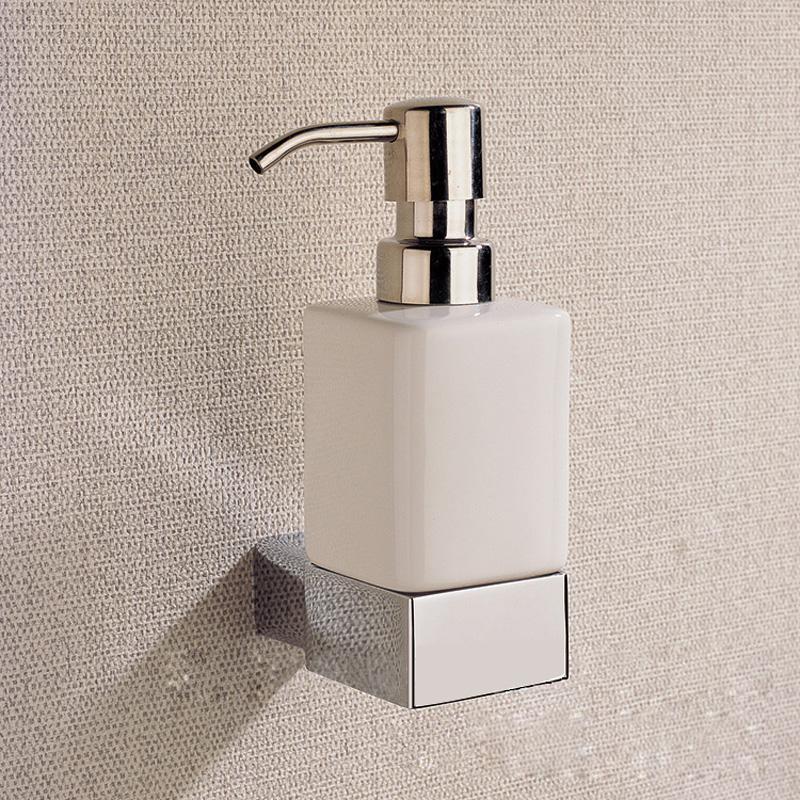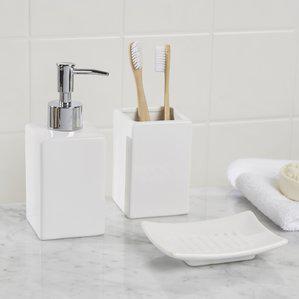The first image is the image on the left, the second image is the image on the right. For the images displayed, is the sentence "In one of the images, a person's hand is visible using a soap dispenser" factually correct? Answer yes or no. No. The first image is the image on the left, the second image is the image on the right. For the images displayed, is the sentence "a human hand is dispensing soap" factually correct? Answer yes or no. No. 